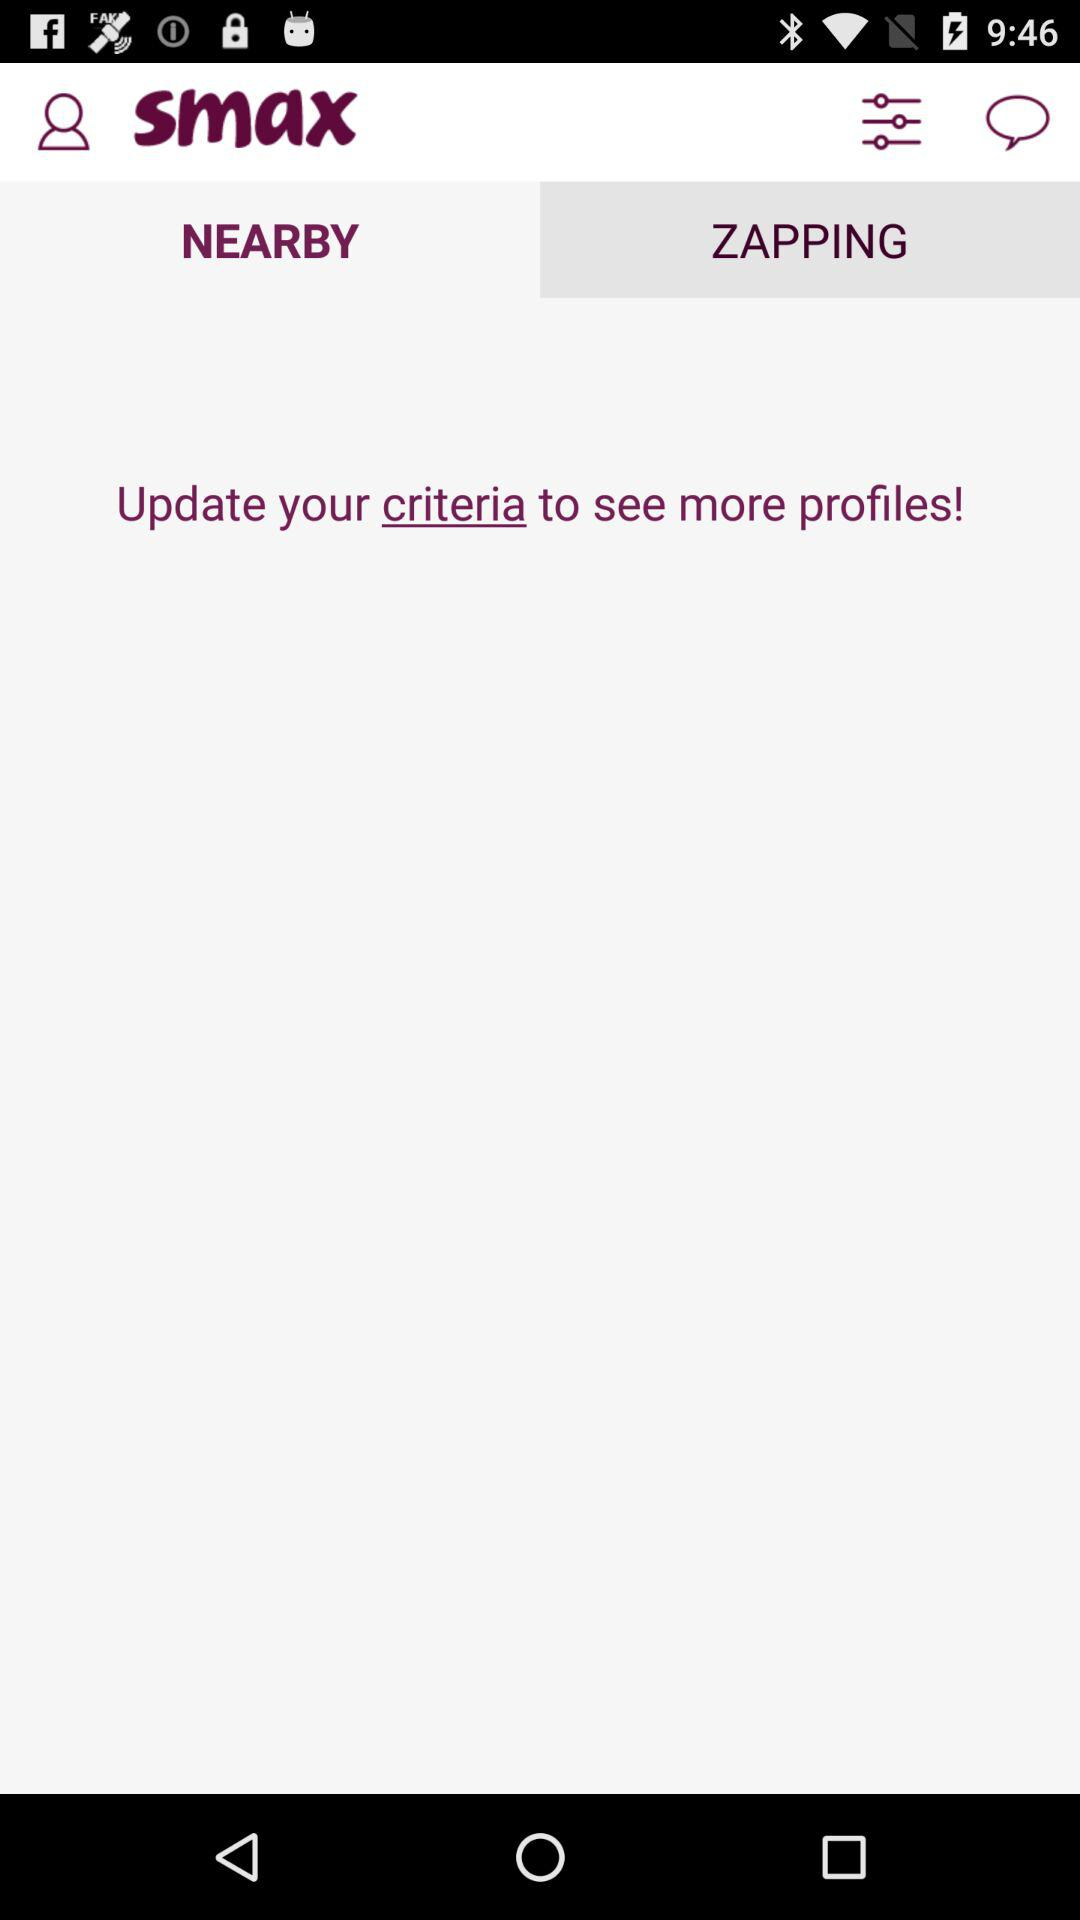Which tab am I on? You are on the tab "NEARBY". 